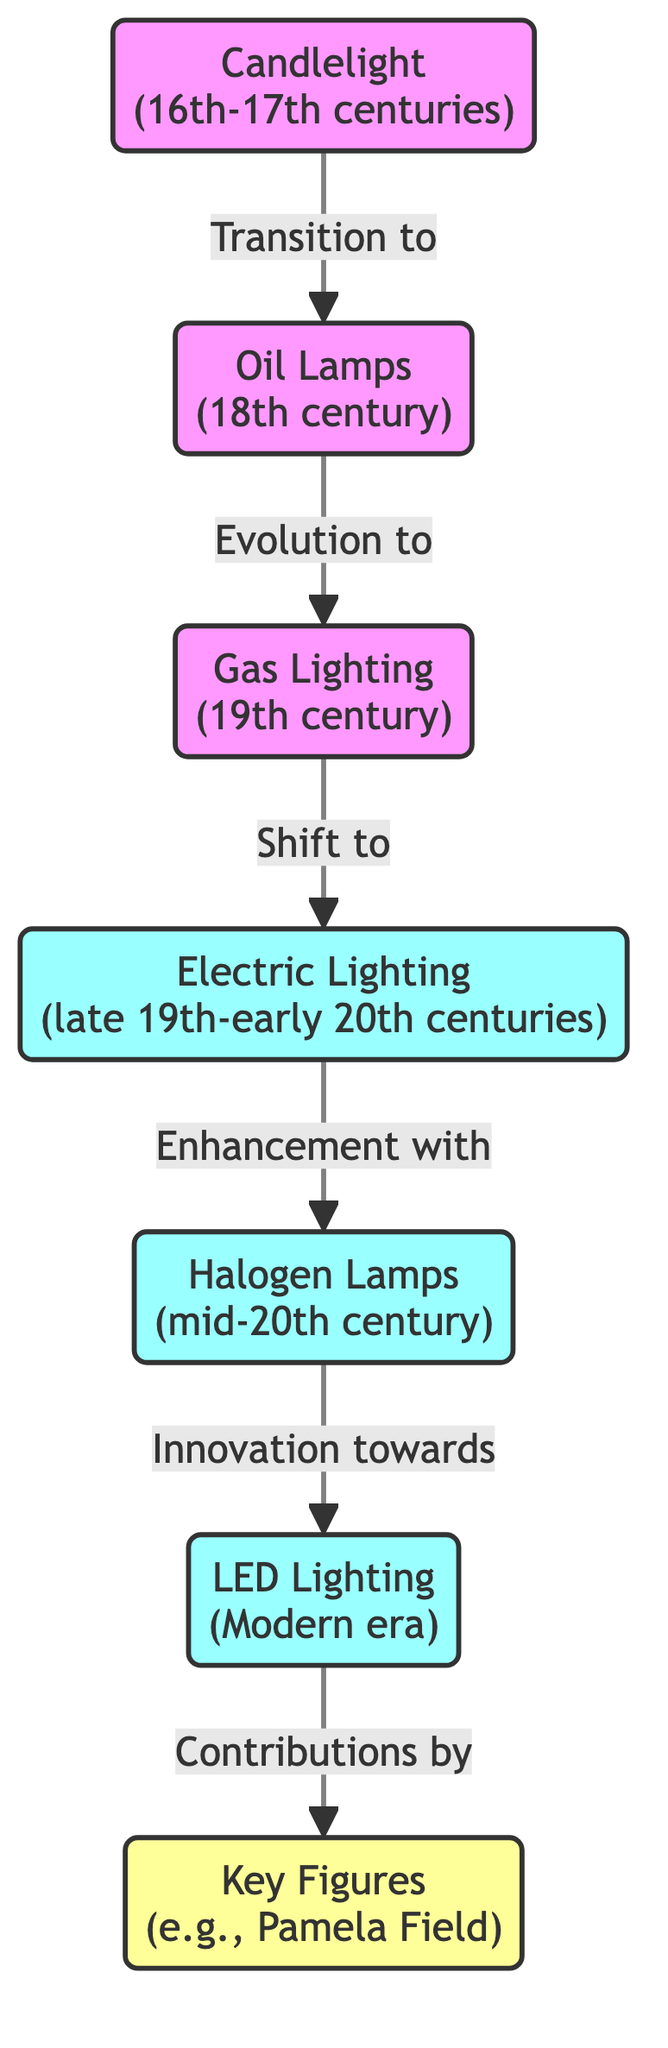What is the first stage of lighting technology in opera? The diagram starts with the "Candlelight" node, indicating that it is the first stage of lighting technology in opera.
Answer: Candlelight Which lighting technology follows oil lamps? The flow from "Oil Lamps" leads to "Gas Lighting," showing that gas lighting is the next evolution after oil lamps.
Answer: Gas Lighting How many key figures are mentioned in the diagram? The diagram has a single node labeled "Key Figures," which suggests that while there may be many individuals associated with advancements, the node captures the concept with one label.
Answer: 1 What stage of lighting technology was used during the late 19th to early 20th centuries? The diagram explicitly labels the node "Electric Lighting," which corresponds to that time period in opera's lighting technology evolution.
Answer: Electric Lighting What type of lighting technology innovates towards LED? The transition from "Halogen Lamps" to "LED Lighting" indicates that halogen lamps are the type of lighting technology that innovates towards LED.
Answer: Halogen Lamps Which lighting technology was used in the 18th century? The diagram specifies "Oil Lamps" as the technology utilized during the 18th century as indicated in its node.
Answer: Oil Lamps What links the node "Halogen Lamps" to "LED Lighting"? The diagram shows that "Halogen Lamps" leads to "LED Lighting" with the description "Innovation towards," denoting the relationship between the two stages.
Answer: Innovation towards How many lighting technologies are displayed in the diagram? By counting the nodes from "Candlelight" to "LED Lighting," and including the "Key Figures" node, there are a total of six distinct lighting technologies represented.
Answer: 6 Who contributed to the final stage of lighting technology? The final node "Key Figures" indicates that contributions to LED lighting, the modern stage, were made by notable individuals, which could be broadly interpreted to include Pamela Field and others.
Answer: Key Figures 